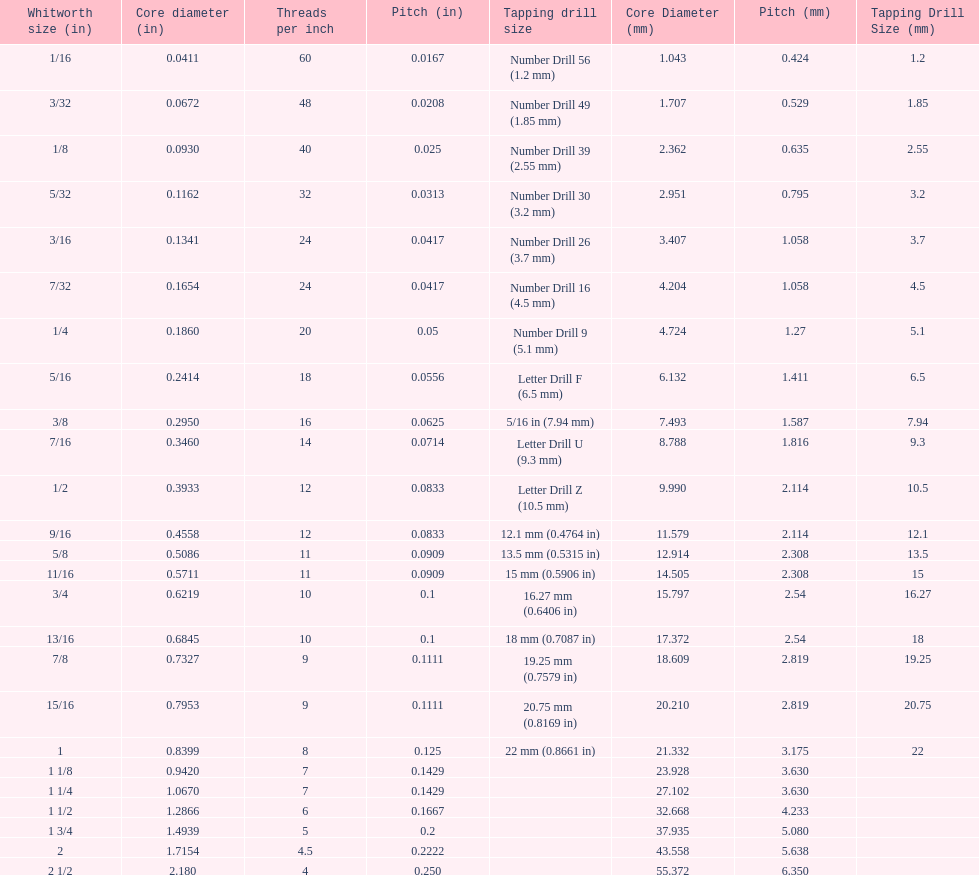What is the total of the first two core diameters? 0.1083. 